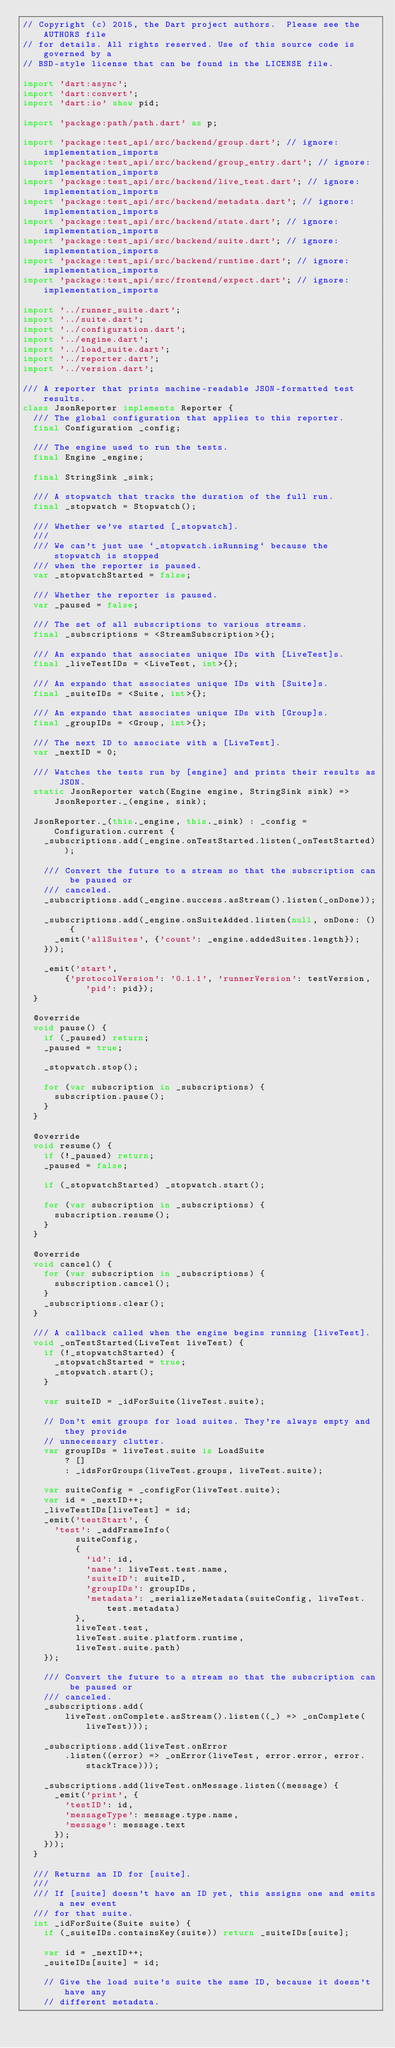<code> <loc_0><loc_0><loc_500><loc_500><_Dart_>// Copyright (c) 2015, the Dart project authors.  Please see the AUTHORS file
// for details. All rights reserved. Use of this source code is governed by a
// BSD-style license that can be found in the LICENSE file.

import 'dart:async';
import 'dart:convert';
import 'dart:io' show pid;

import 'package:path/path.dart' as p;

import 'package:test_api/src/backend/group.dart'; // ignore: implementation_imports
import 'package:test_api/src/backend/group_entry.dart'; // ignore: implementation_imports
import 'package:test_api/src/backend/live_test.dart'; // ignore: implementation_imports
import 'package:test_api/src/backend/metadata.dart'; // ignore: implementation_imports
import 'package:test_api/src/backend/state.dart'; // ignore: implementation_imports
import 'package:test_api/src/backend/suite.dart'; // ignore: implementation_imports
import 'package:test_api/src/backend/runtime.dart'; // ignore: implementation_imports
import 'package:test_api/src/frontend/expect.dart'; // ignore: implementation_imports

import '../runner_suite.dart';
import '../suite.dart';
import '../configuration.dart';
import '../engine.dart';
import '../load_suite.dart';
import '../reporter.dart';
import '../version.dart';

/// A reporter that prints machine-readable JSON-formatted test results.
class JsonReporter implements Reporter {
  /// The global configuration that applies to this reporter.
  final Configuration _config;

  /// The engine used to run the tests.
  final Engine _engine;

  final StringSink _sink;

  /// A stopwatch that tracks the duration of the full run.
  final _stopwatch = Stopwatch();

  /// Whether we've started [_stopwatch].
  ///
  /// We can't just use `_stopwatch.isRunning` because the stopwatch is stopped
  /// when the reporter is paused.
  var _stopwatchStarted = false;

  /// Whether the reporter is paused.
  var _paused = false;

  /// The set of all subscriptions to various streams.
  final _subscriptions = <StreamSubscription>{};

  /// An expando that associates unique IDs with [LiveTest]s.
  final _liveTestIDs = <LiveTest, int>{};

  /// An expando that associates unique IDs with [Suite]s.
  final _suiteIDs = <Suite, int>{};

  /// An expando that associates unique IDs with [Group]s.
  final _groupIDs = <Group, int>{};

  /// The next ID to associate with a [LiveTest].
  var _nextID = 0;

  /// Watches the tests run by [engine] and prints their results as JSON.
  static JsonReporter watch(Engine engine, StringSink sink) =>
      JsonReporter._(engine, sink);

  JsonReporter._(this._engine, this._sink) : _config = Configuration.current {
    _subscriptions.add(_engine.onTestStarted.listen(_onTestStarted));

    /// Convert the future to a stream so that the subscription can be paused or
    /// canceled.
    _subscriptions.add(_engine.success.asStream().listen(_onDone));

    _subscriptions.add(_engine.onSuiteAdded.listen(null, onDone: () {
      _emit('allSuites', {'count': _engine.addedSuites.length});
    }));

    _emit('start',
        {'protocolVersion': '0.1.1', 'runnerVersion': testVersion, 'pid': pid});
  }

  @override
  void pause() {
    if (_paused) return;
    _paused = true;

    _stopwatch.stop();

    for (var subscription in _subscriptions) {
      subscription.pause();
    }
  }

  @override
  void resume() {
    if (!_paused) return;
    _paused = false;

    if (_stopwatchStarted) _stopwatch.start();

    for (var subscription in _subscriptions) {
      subscription.resume();
    }
  }

  @override
  void cancel() {
    for (var subscription in _subscriptions) {
      subscription.cancel();
    }
    _subscriptions.clear();
  }

  /// A callback called when the engine begins running [liveTest].
  void _onTestStarted(LiveTest liveTest) {
    if (!_stopwatchStarted) {
      _stopwatchStarted = true;
      _stopwatch.start();
    }

    var suiteID = _idForSuite(liveTest.suite);

    // Don't emit groups for load suites. They're always empty and they provide
    // unnecessary clutter.
    var groupIDs = liveTest.suite is LoadSuite
        ? []
        : _idsForGroups(liveTest.groups, liveTest.suite);

    var suiteConfig = _configFor(liveTest.suite);
    var id = _nextID++;
    _liveTestIDs[liveTest] = id;
    _emit('testStart', {
      'test': _addFrameInfo(
          suiteConfig,
          {
            'id': id,
            'name': liveTest.test.name,
            'suiteID': suiteID,
            'groupIDs': groupIDs,
            'metadata': _serializeMetadata(suiteConfig, liveTest.test.metadata)
          },
          liveTest.test,
          liveTest.suite.platform.runtime,
          liveTest.suite.path)
    });

    /// Convert the future to a stream so that the subscription can be paused or
    /// canceled.
    _subscriptions.add(
        liveTest.onComplete.asStream().listen((_) => _onComplete(liveTest)));

    _subscriptions.add(liveTest.onError
        .listen((error) => _onError(liveTest, error.error, error.stackTrace)));

    _subscriptions.add(liveTest.onMessage.listen((message) {
      _emit('print', {
        'testID': id,
        'messageType': message.type.name,
        'message': message.text
      });
    }));
  }

  /// Returns an ID for [suite].
  ///
  /// If [suite] doesn't have an ID yet, this assigns one and emits a new event
  /// for that suite.
  int _idForSuite(Suite suite) {
    if (_suiteIDs.containsKey(suite)) return _suiteIDs[suite];

    var id = _nextID++;
    _suiteIDs[suite] = id;

    // Give the load suite's suite the same ID, because it doesn't have any
    // different metadata.</code> 